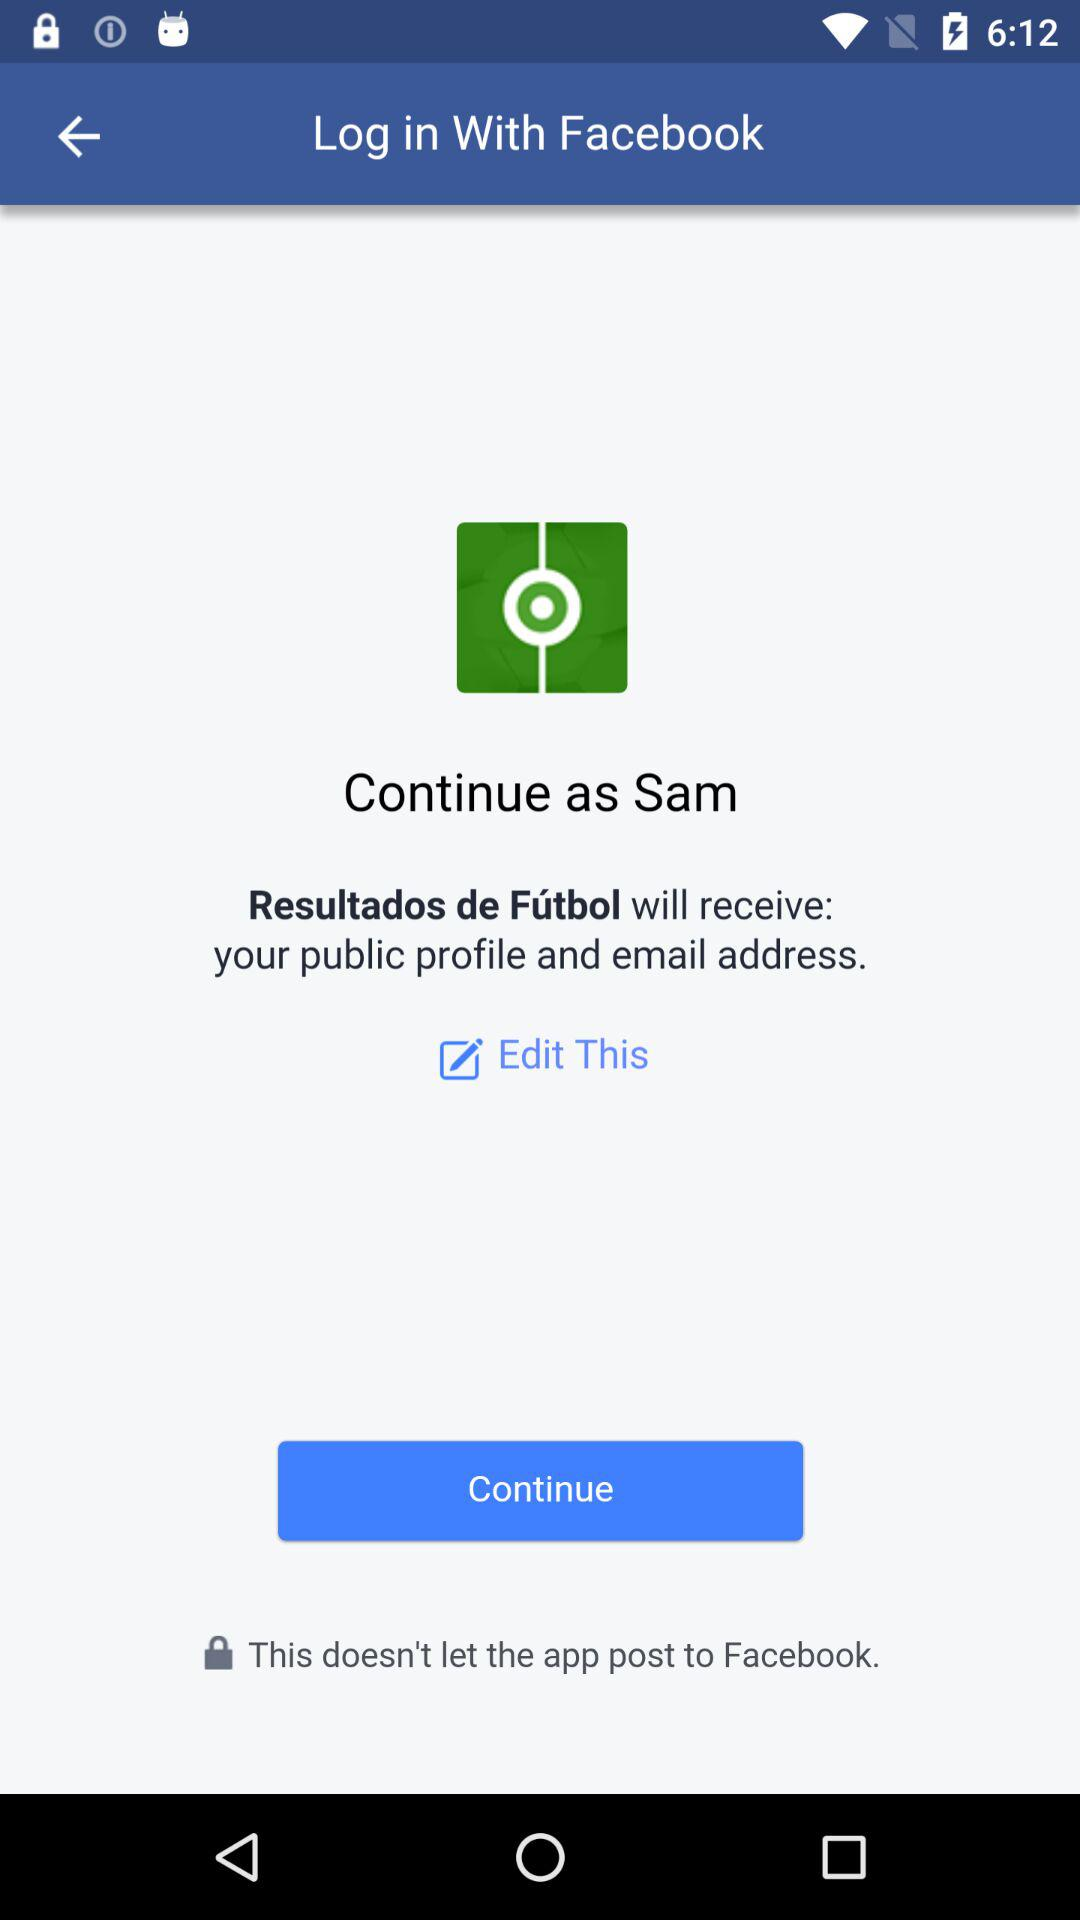What application is asking for permission? The application asking for permission is "Resultados de Fútbol". 